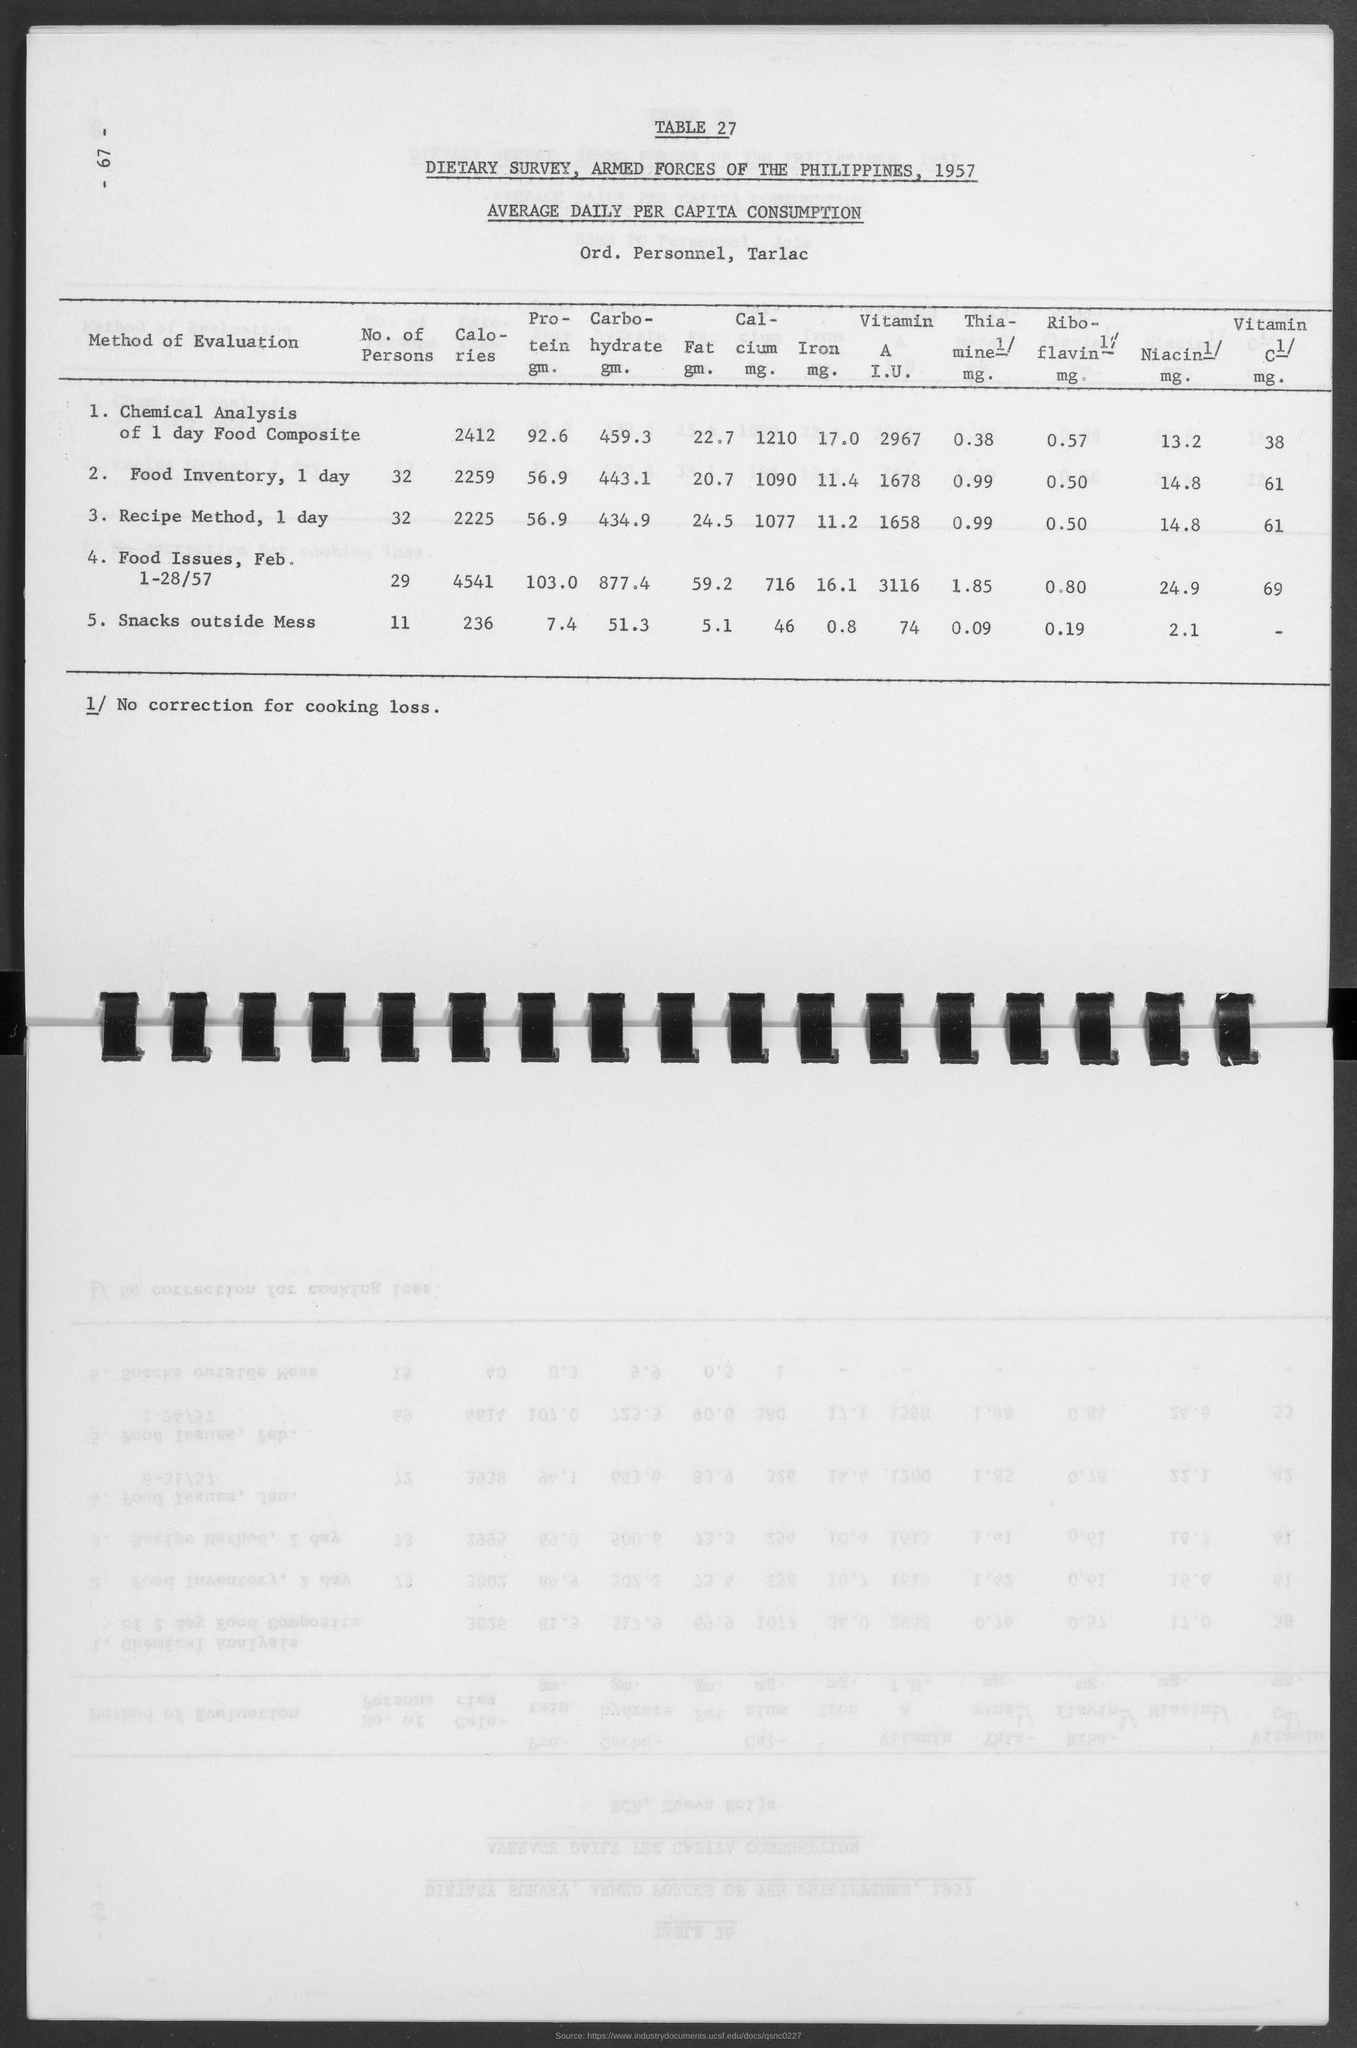Point out several critical features in this image. The Philippines is mentioned in the title. The value for "Recipe Method, 1 day" under the column "Fat gm." is 24.5 grams. The year mentioned in the topic is 1957. The value of "Riboflavin 1/mg." for snacks outside the mess is 0.19. 